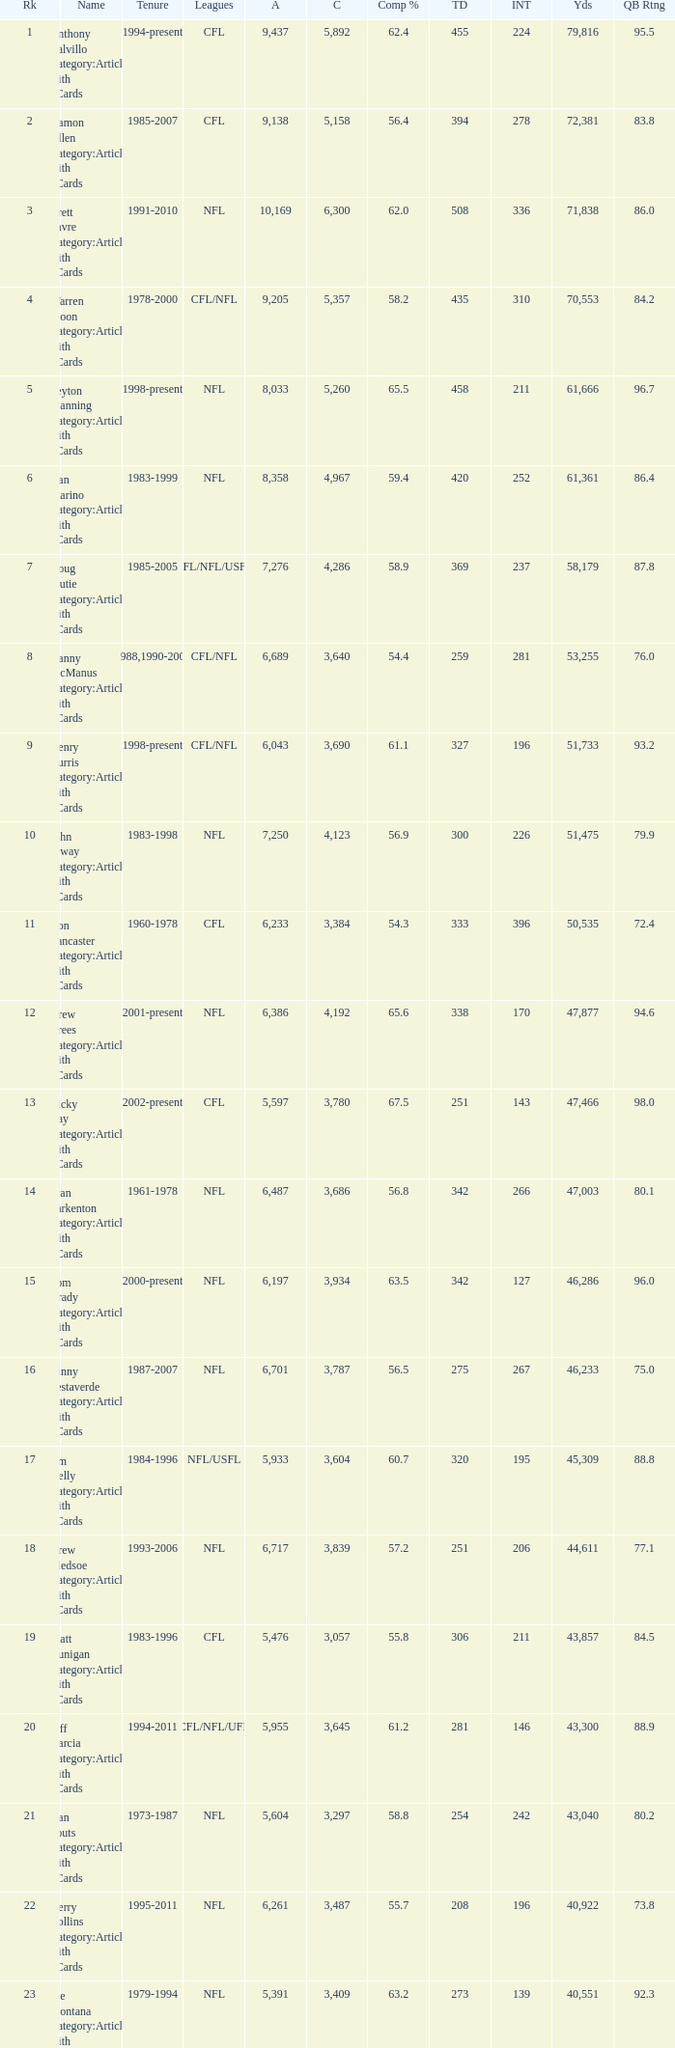What is the number of interceptions with less than 3,487 completions , more than 40,551 yardage, and the comp % is 55.8? 211.0. 